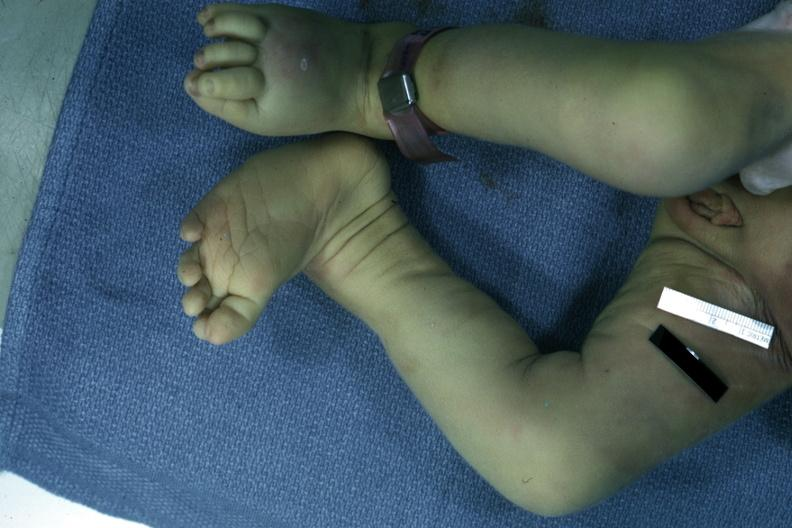s this photo of infant from head to toe left club foot?
Answer the question using a single word or phrase. No 